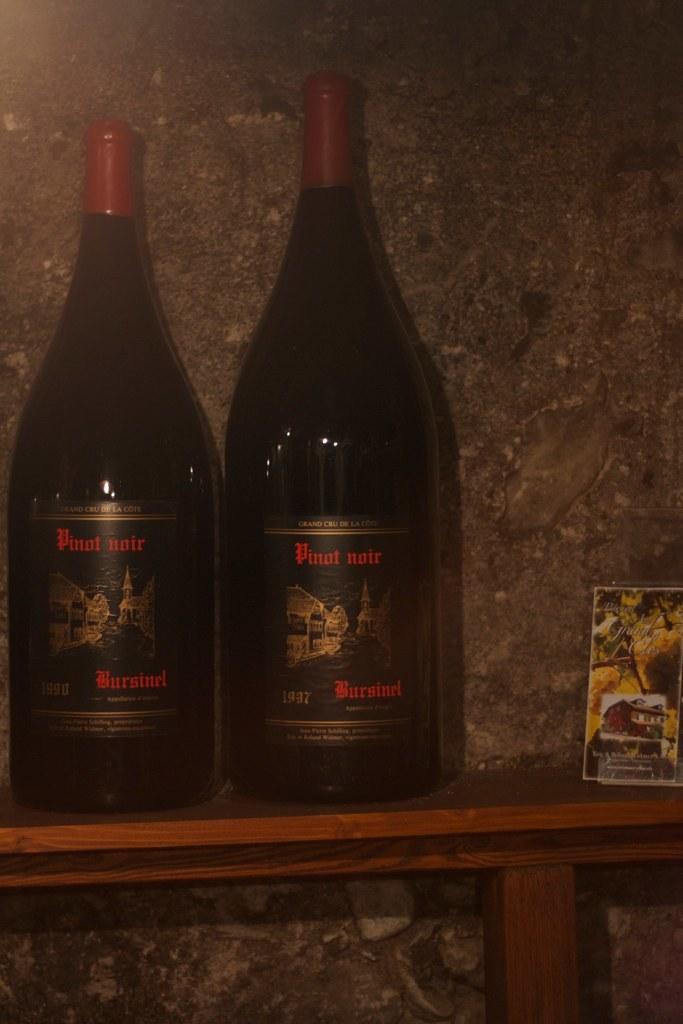What is in the bottle?
Keep it short and to the point. Pinot noir. What kind of wine is this?
Give a very brief answer. Pinot noir. 